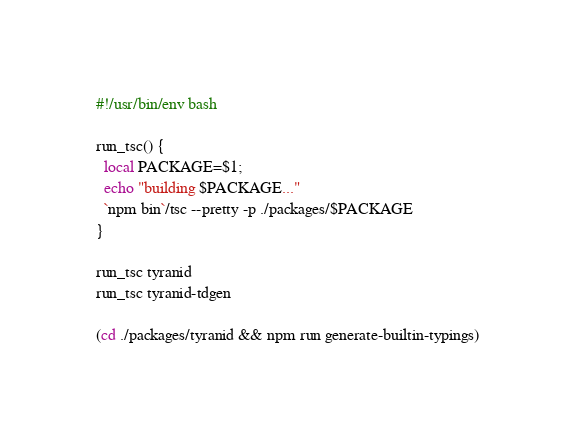<code> <loc_0><loc_0><loc_500><loc_500><_Bash_>#!/usr/bin/env bash

run_tsc() {
  local PACKAGE=$1;
  echo "building $PACKAGE..."
  `npm bin`/tsc --pretty -p ./packages/$PACKAGE
}

run_tsc tyranid
run_tsc tyranid-tdgen

(cd ./packages/tyranid && npm run generate-builtin-typings)
</code> 